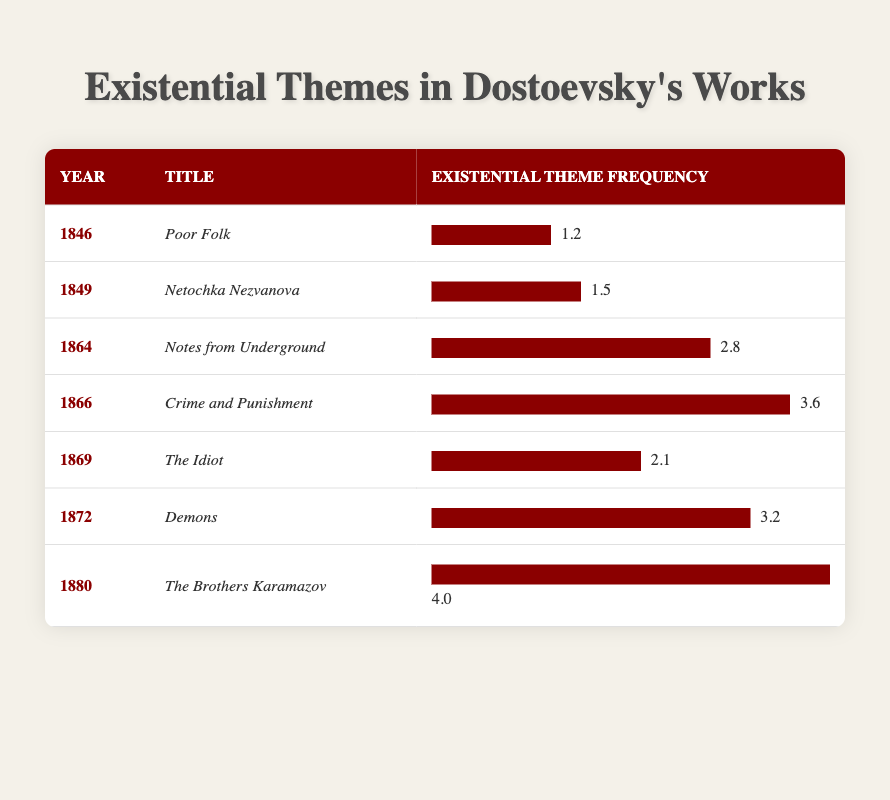What is the existential theme frequency of "Crime and Punishment"? The table provides the specific frequency for "Crime and Punishment," which is listed under the publication year 1866. By finding that specific row, we see that the existential theme frequency is 3.6.
Answer: 3.6 Which work has the highest frequency of existential themes? By examining the last column of the table, we look for the maximum value in the existential theme frequencies. The highest frequency is located in the row for "The Brothers Karamazov," published in 1880, with a frequency of 4.0.
Answer: The Brothers Karamazov What is the average frequency of existential themes for the works published before 1870? To find the average frequency for works published before 1870, we need to focus on the relevant entries: "Poor Folk" (1.2), "Netochka Nezvanova" (1.5), "Notes from Underground" (2.8), "Crime and Punishment" (3.6), "The Idiot" (2.1), and "Demons" (3.2). Adding these values gives 14.4. There are 6 works in total, so the average is 14.4 divided by 6, which equals 2.4.
Answer: 2.4 Did Dostoevsky's exploration of existential themes increase over time according to the table? By analyzing the data across publication years, we note that the frequencies generally rise from 1.2 in 1846 to 4.0 in 1880. This trend indicates an increase in the frequency of existential themes over time as the years progress.
Answer: Yes What is the difference between the existential theme frequency of "The Brothers Karamazov" and "Demons"? "The Brothers Karamazov" has an existential theme frequency of 4.0 while "Demons" has a frequency of 3.2. To find the difference, we subtract 3.2 from 4.0, which yields a difference of 0.8.
Answer: 0.8 